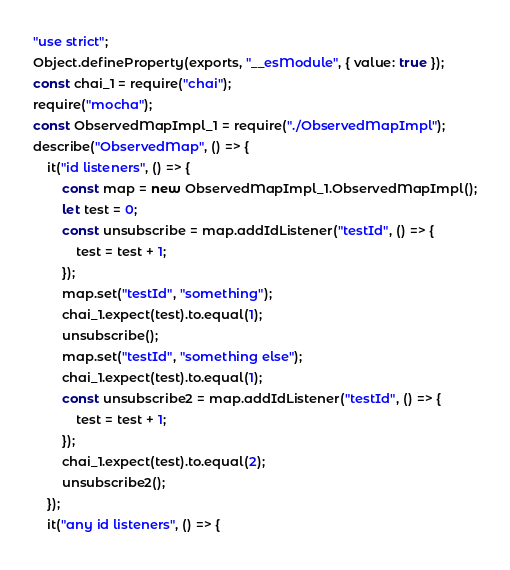Convert code to text. <code><loc_0><loc_0><loc_500><loc_500><_JavaScript_>"use strict";
Object.defineProperty(exports, "__esModule", { value: true });
const chai_1 = require("chai");
require("mocha");
const ObservedMapImpl_1 = require("./ObservedMapImpl");
describe("ObservedMap", () => {
    it("id listeners", () => {
        const map = new ObservedMapImpl_1.ObservedMapImpl();
        let test = 0;
        const unsubscribe = map.addIdListener("testId", () => {
            test = test + 1;
        });
        map.set("testId", "something");
        chai_1.expect(test).to.equal(1);
        unsubscribe();
        map.set("testId", "something else");
        chai_1.expect(test).to.equal(1);
        const unsubscribe2 = map.addIdListener("testId", () => {
            test = test + 1;
        });
        chai_1.expect(test).to.equal(2);
        unsubscribe2();
    });
    it("any id listeners", () => {</code> 